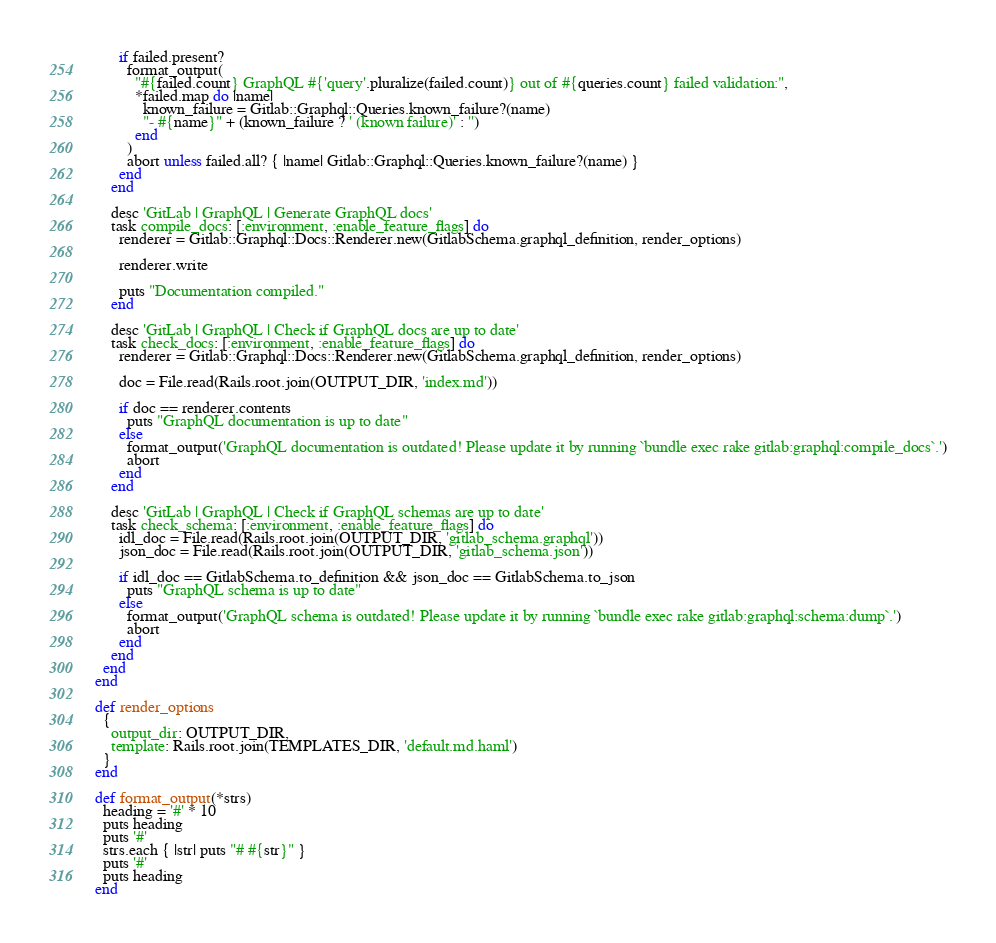Convert code to text. <code><loc_0><loc_0><loc_500><loc_500><_Ruby_>
      if failed.present?
        format_output(
          "#{failed.count} GraphQL #{'query'.pluralize(failed.count)} out of #{queries.count} failed validation:",
          *failed.map do |name|
            known_failure = Gitlab::Graphql::Queries.known_failure?(name)
            "- #{name}" + (known_failure ? ' (known failure)' : '')
          end
        )
        abort unless failed.all? { |name| Gitlab::Graphql::Queries.known_failure?(name) }
      end
    end

    desc 'GitLab | GraphQL | Generate GraphQL docs'
    task compile_docs: [:environment, :enable_feature_flags] do
      renderer = Gitlab::Graphql::Docs::Renderer.new(GitlabSchema.graphql_definition, render_options)

      renderer.write

      puts "Documentation compiled."
    end

    desc 'GitLab | GraphQL | Check if GraphQL docs are up to date'
    task check_docs: [:environment, :enable_feature_flags] do
      renderer = Gitlab::Graphql::Docs::Renderer.new(GitlabSchema.graphql_definition, render_options)

      doc = File.read(Rails.root.join(OUTPUT_DIR, 'index.md'))

      if doc == renderer.contents
        puts "GraphQL documentation is up to date"
      else
        format_output('GraphQL documentation is outdated! Please update it by running `bundle exec rake gitlab:graphql:compile_docs`.')
        abort
      end
    end

    desc 'GitLab | GraphQL | Check if GraphQL schemas are up to date'
    task check_schema: [:environment, :enable_feature_flags] do
      idl_doc = File.read(Rails.root.join(OUTPUT_DIR, 'gitlab_schema.graphql'))
      json_doc = File.read(Rails.root.join(OUTPUT_DIR, 'gitlab_schema.json'))

      if idl_doc == GitlabSchema.to_definition && json_doc == GitlabSchema.to_json
        puts "GraphQL schema is up to date"
      else
        format_output('GraphQL schema is outdated! Please update it by running `bundle exec rake gitlab:graphql:schema:dump`.')
        abort
      end
    end
  end
end

def render_options
  {
    output_dir: OUTPUT_DIR,
    template: Rails.root.join(TEMPLATES_DIR, 'default.md.haml')
  }
end

def format_output(*strs)
  heading = '#' * 10
  puts heading
  puts '#'
  strs.each { |str| puts "# #{str}" }
  puts '#'
  puts heading
end
</code> 